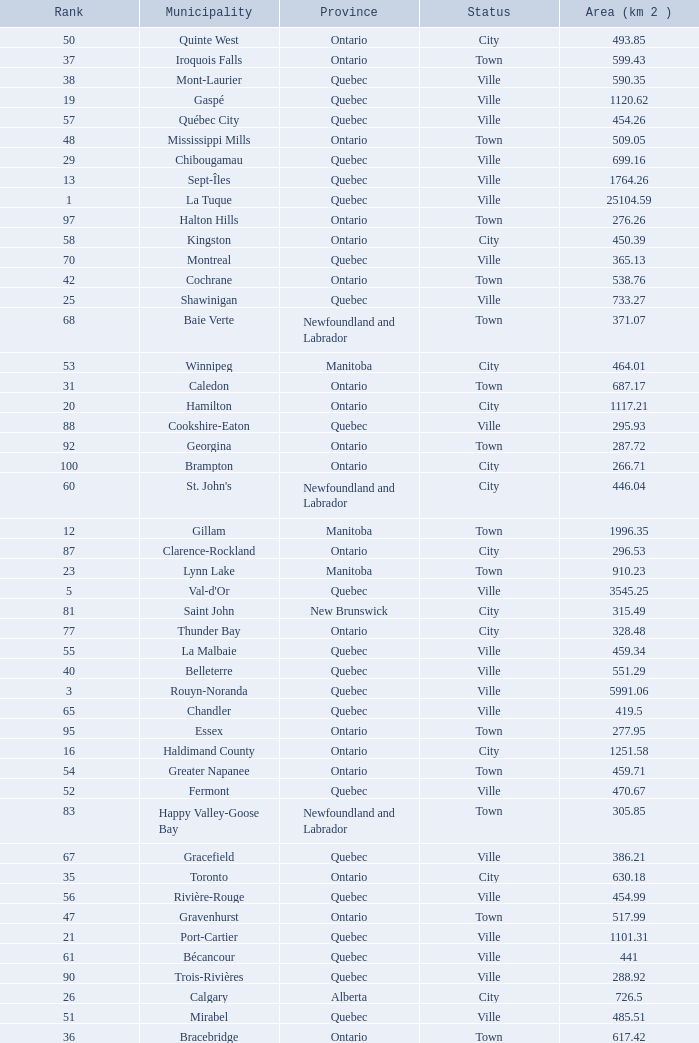What is the total Rank that has a Municipality of Winnipeg, an Area (KM 2) that's larger than 464.01? None. 